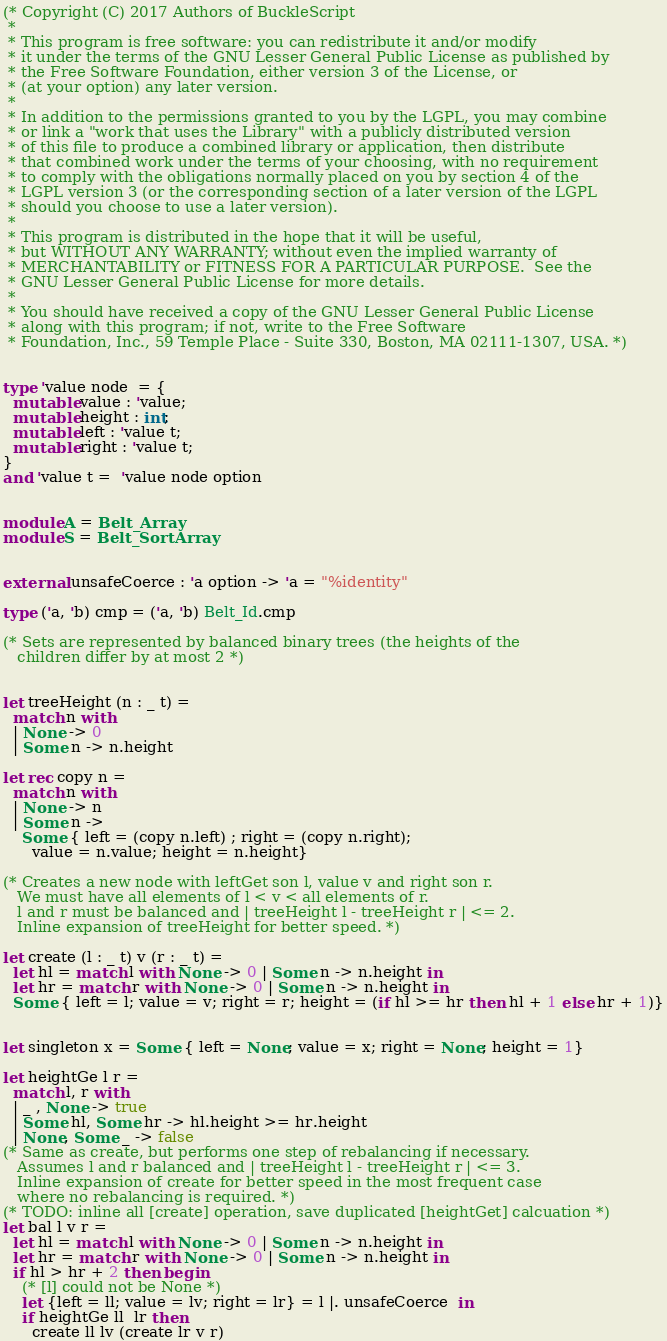<code> <loc_0><loc_0><loc_500><loc_500><_OCaml_>
(* Copyright (C) 2017 Authors of BuckleScript
 *
 * This program is free software: you can redistribute it and/or modify
 * it under the terms of the GNU Lesser General Public License as published by
 * the Free Software Foundation, either version 3 of the License, or
 * (at your option) any later version.
 *
 * In addition to the permissions granted to you by the LGPL, you may combine
 * or link a "work that uses the Library" with a publicly distributed version
 * of this file to produce a combined library or application, then distribute
 * that combined work under the terms of your choosing, with no requirement
 * to comply with the obligations normally placed on you by section 4 of the
 * LGPL version 3 (or the corresponding section of a later version of the LGPL
 * should you choose to use a later version).
 *
 * This program is distributed in the hope that it will be useful,
 * but WITHOUT ANY WARRANTY; without even the implied warranty of
 * MERCHANTABILITY or FITNESS FOR A PARTICULAR PURPOSE.  See the
 * GNU Lesser General Public License for more details.
 *
 * You should have received a copy of the GNU Lesser General Public License
 * along with this program; if not, write to the Free Software
 * Foundation, Inc., 59 Temple Place - Suite 330, Boston, MA 02111-1307, USA. *)


type 'value node  = {
  mutable value : 'value;
  mutable height : int;
  mutable left : 'value t;
  mutable right : 'value t;
}
and 'value t =  'value node option


module A = Belt_Array
module S = Belt_SortArray


external unsafeCoerce : 'a option -> 'a = "%identity"

type ('a, 'b) cmp = ('a, 'b) Belt_Id.cmp

(* Sets are represented by balanced binary trees (the heights of the
   children differ by at most 2 *)


let treeHeight (n : _ t) =
  match n with
  | None -> 0
  | Some n -> n.height

let rec copy n =
  match n with
  | None -> n
  | Some n ->
    Some { left = (copy n.left) ; right = (copy n.right);
      value = n.value; height = n.height}
    
(* Creates a new node with leftGet son l, value v and right son r.
   We must have all elements of l < v < all elements of r.
   l and r must be balanced and | treeHeight l - treeHeight r | <= 2.
   Inline expansion of treeHeight for better speed. *)

let create (l : _ t) v (r : _ t) =
  let hl = match l with None -> 0 | Some n -> n.height in
  let hr = match r with None -> 0 | Some n -> n.height in
  Some { left = l; value = v; right = r; height = (if hl >= hr then hl + 1 else hr + 1)}
  

let singleton x = Some { left = None; value = x; right = None; height = 1} 

let heightGe l r =
  match l, r with
  | _ , None -> true
  | Some hl, Some hr -> hl.height >= hr.height
  | None, Some _ -> false
(* Same as create, but performs one step of rebalancing if necessary.
   Assumes l and r balanced and | treeHeight l - treeHeight r | <= 3.
   Inline expansion of create for better speed in the most frequent case
   where no rebalancing is required. *)
(* TODO: inline all [create] operation, save duplicated [heightGet] calcuation *)
let bal l v r =
  let hl = match l with None -> 0 | Some n -> n.height in
  let hr = match r with None -> 0 | Some n -> n.height in
  if hl > hr + 2 then begin
    (* [l] could not be None *)
    let {left = ll; value = lv; right = lr} = l |. unsafeCoerce  in
    if heightGe ll  lr then
      create ll lv (create lr v r)</code> 